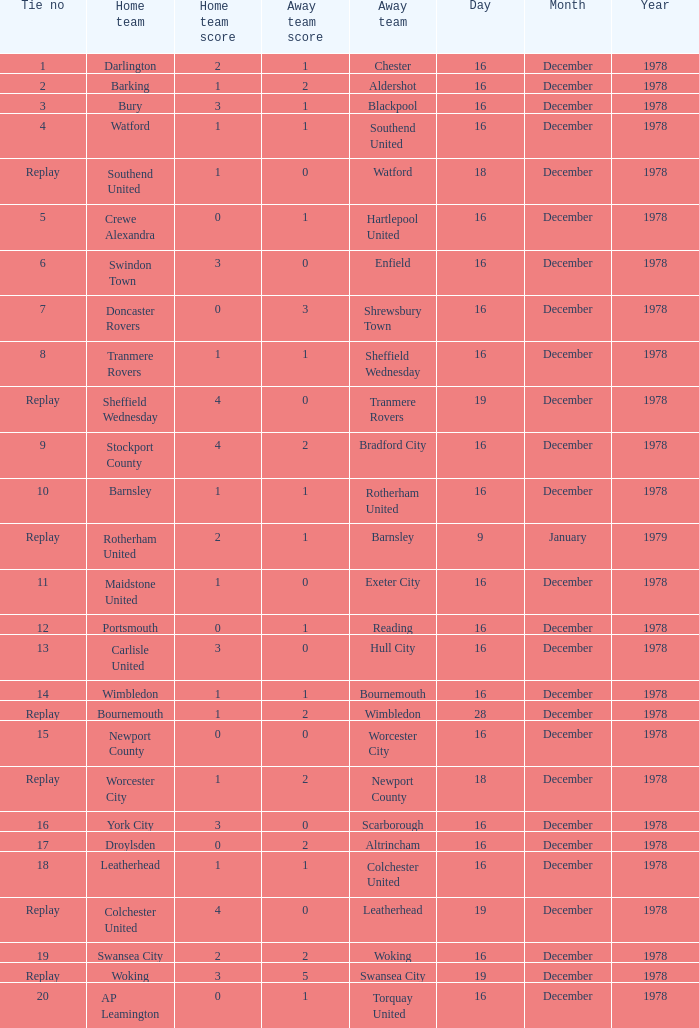What is the tie no for the away team altrincham? 17.0. 